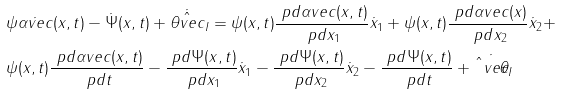<formula> <loc_0><loc_0><loc_500><loc_500>& \psi \dot { \alpha v e c } ( x , t ) - \dot { \Psi } ( x , t ) + \dot { \hat { \theta v e c } } _ { I } = \psi ( x , t ) \frac { \ p d \alpha v e c ( x , t ) } { \ p d x _ { 1 } } \dot { x } _ { 1 } + \psi ( x , t ) \frac { \ p d \alpha v e c ( x ) } { \ p d x _ { 2 } } \dot { x } _ { 2 } + \\ & \psi ( x , t ) \frac { \ p d \alpha v e c ( x , t ) } { \ p d t } - \frac { \ p d \Psi ( x , t ) } { \ p d x _ { 1 } } \dot { x } _ { 1 } - \frac { \ p d \Psi ( x , t ) } { \ p d x _ { 2 } } \dot { x } _ { 2 } - \frac { \ p d \Psi ( x , t ) } { \ p d t } + \dot { \hat { \theta } v e c } _ { I }</formula> 